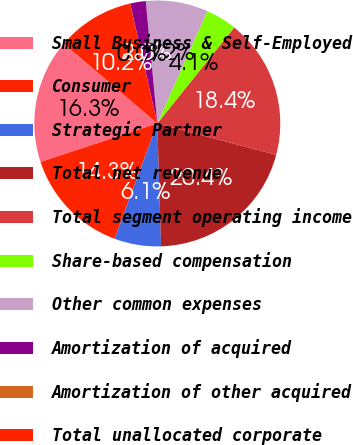<chart> <loc_0><loc_0><loc_500><loc_500><pie_chart><fcel>Small Business & Self-Employed<fcel>Consumer<fcel>Strategic Partner<fcel>Total net revenue<fcel>Total segment operating income<fcel>Share-based compensation<fcel>Other common expenses<fcel>Amortization of acquired<fcel>Amortization of other acquired<fcel>Total unallocated corporate<nl><fcel>16.32%<fcel>14.28%<fcel>6.13%<fcel>20.4%<fcel>18.36%<fcel>4.09%<fcel>8.16%<fcel>2.05%<fcel>0.01%<fcel>10.2%<nl></chart> 